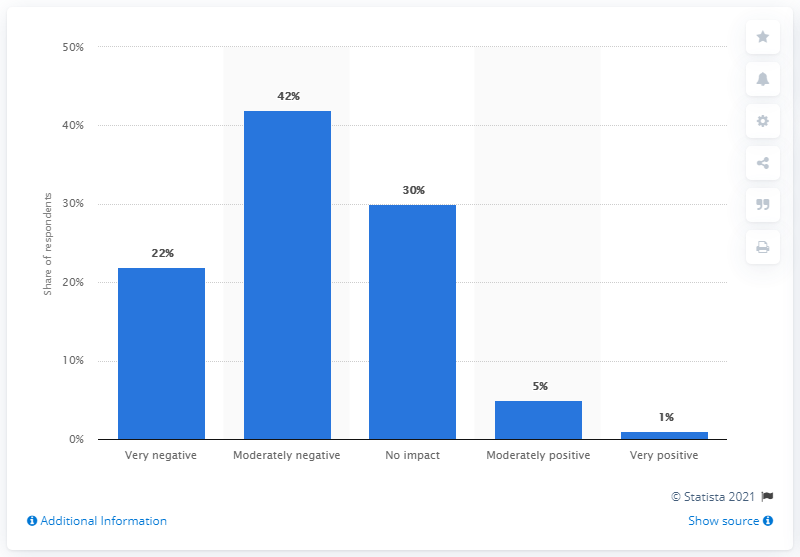Specify some key components in this picture. Thirty percent of Swedish export companies expect no impact from the coronavirus pandemic, according to their recent survey. 